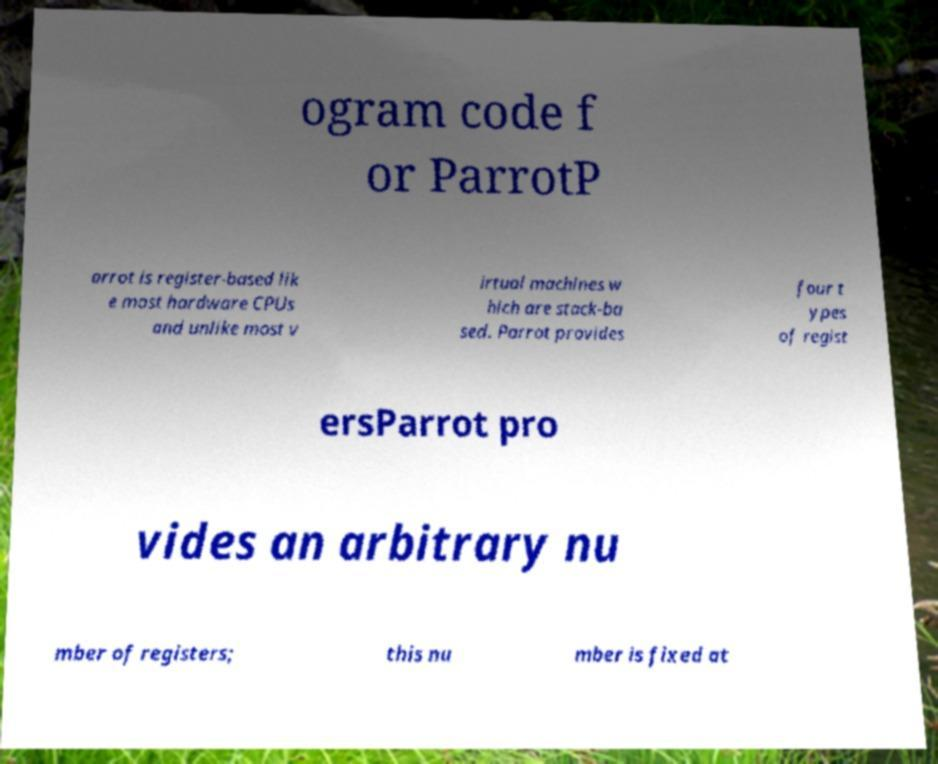Could you assist in decoding the text presented in this image and type it out clearly? ogram code f or ParrotP arrot is register-based lik e most hardware CPUs and unlike most v irtual machines w hich are stack-ba sed. Parrot provides four t ypes of regist ersParrot pro vides an arbitrary nu mber of registers; this nu mber is fixed at 